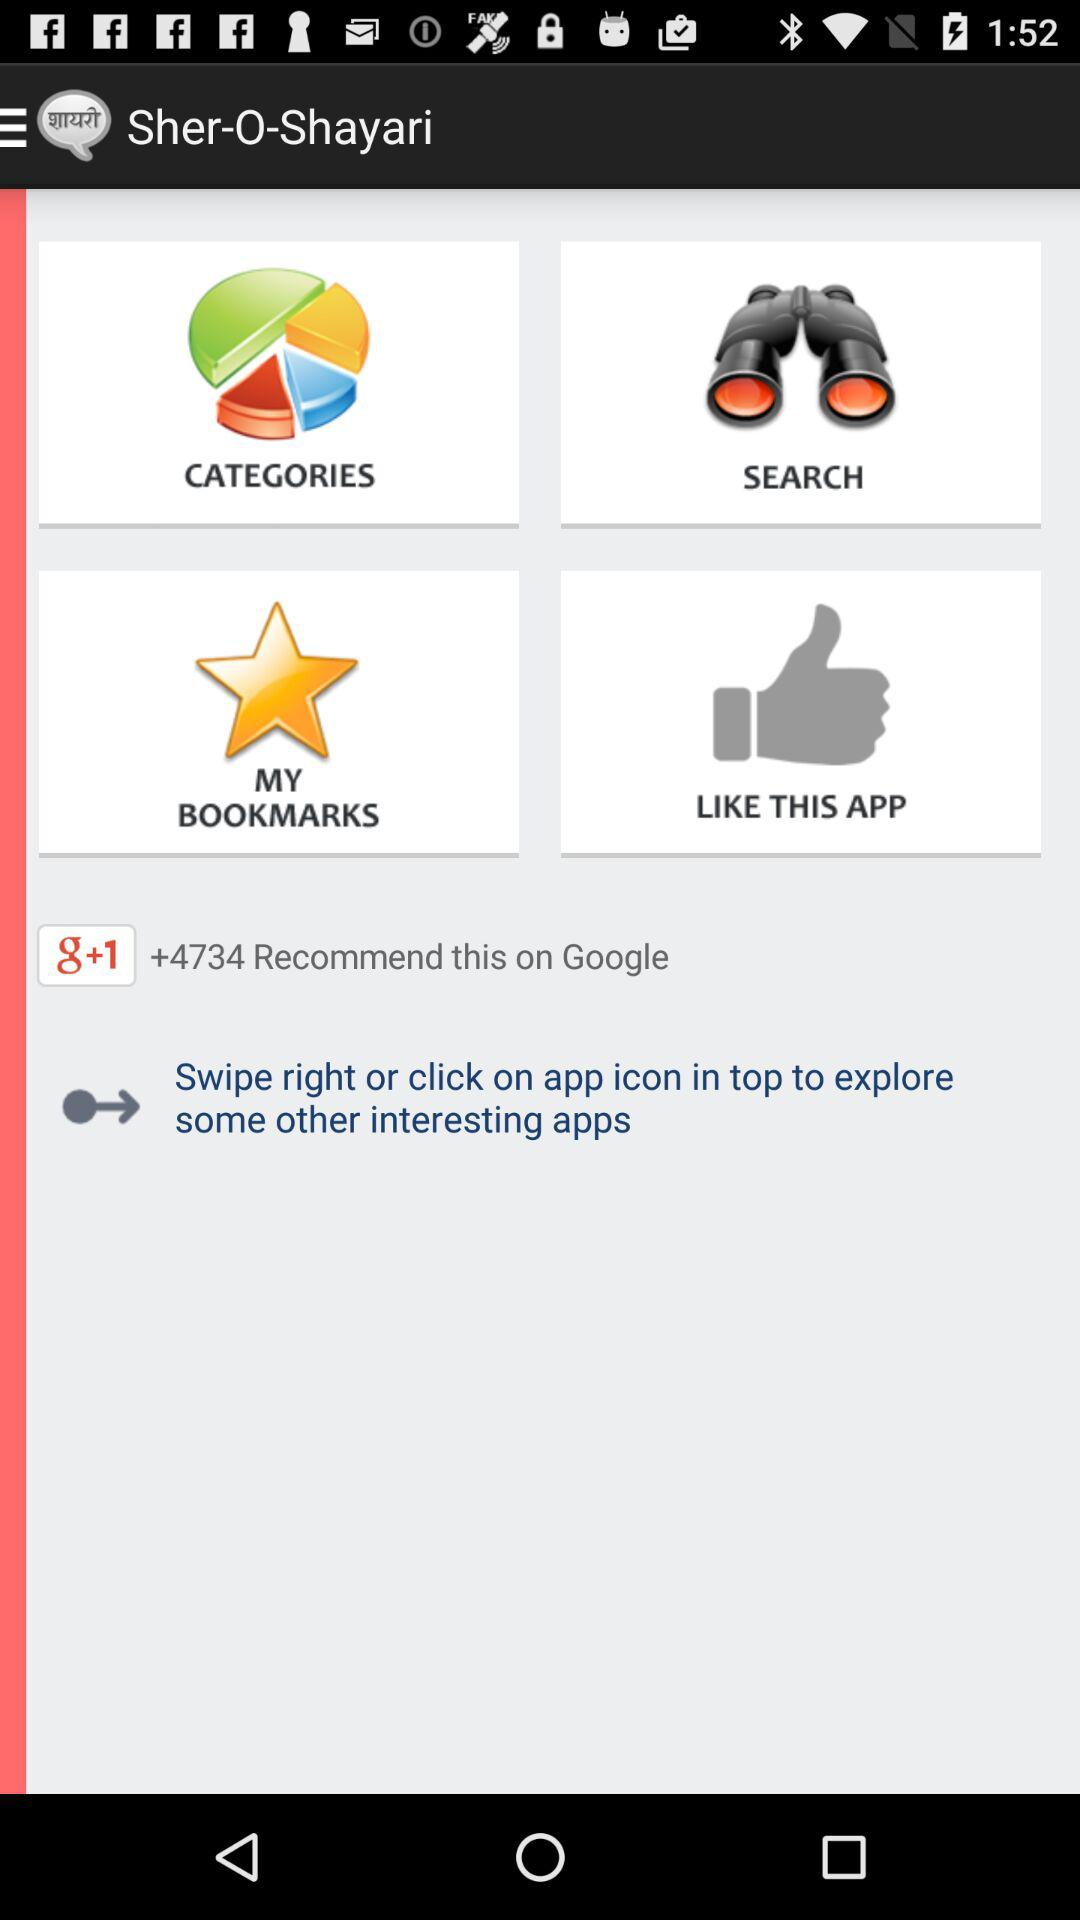What is the name of the application? The name of the application is "Sher-O-Shayari". 